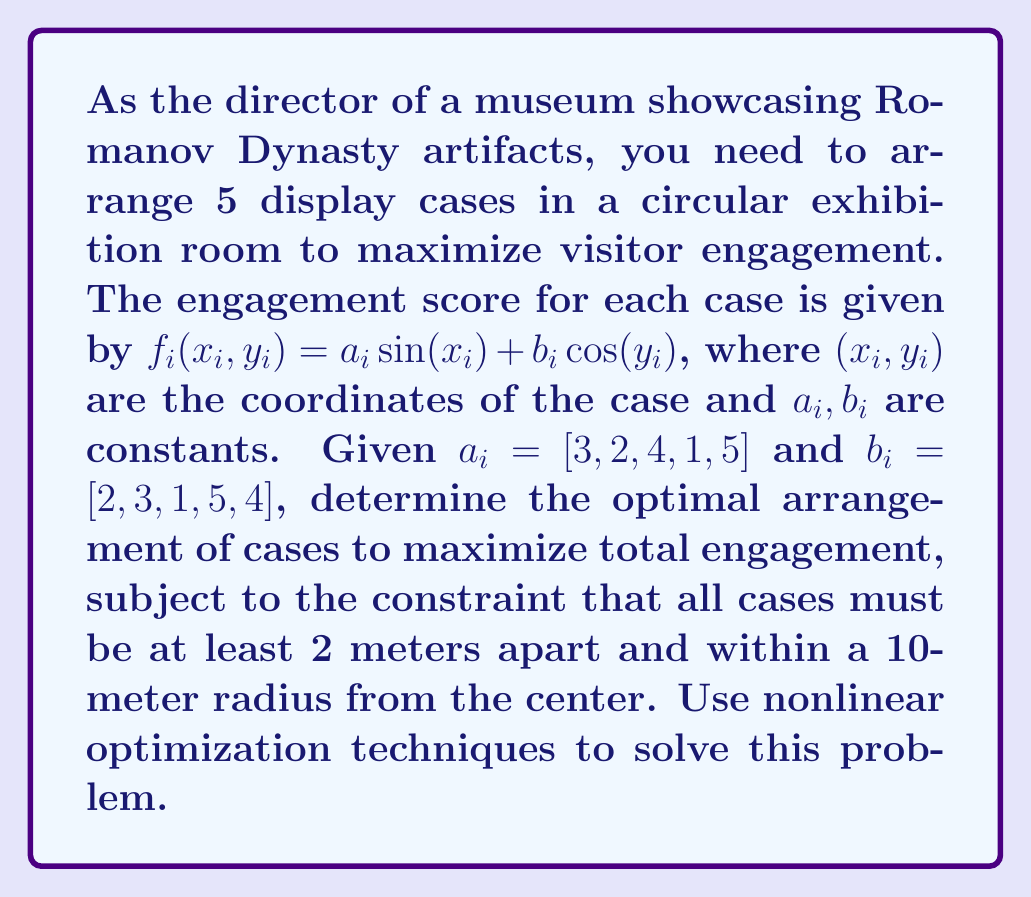Can you answer this question? To solve this nonlinear optimization problem, we'll follow these steps:

1) Define the objective function:
   $$f(x_1,y_1,x_2,y_2,x_3,y_3,x_4,y_4,x_5,y_5) = \sum_{i=1}^5 (a_i \sin(x_i) + b_i \cos(y_i))$$

2) Define the constraints:
   a) Distance between cases: For all $i \neq j$,
      $$\sqrt{(x_i-x_j)^2 + (y_i-y_j)^2} \geq 2$$
   b) Within 10-meter radius:
      $$x_i^2 + y_i^2 \leq 100$$ for all $i$

3) This is a nonlinear programming problem with nonlinear constraints. We can use sequential quadratic programming (SQP) or interior point methods to solve it.

4) Using a numerical optimization software (e.g., MATLAB's fmincon or Python's scipy.optimize.minimize), we can solve this problem. The exact implementation would depend on the software used.

5) The optimization algorithm would iteratively adjust the positions of the cases to maximize the objective function while satisfying the constraints.

6) The solution would provide the optimal $(x_i, y_i)$ coordinates for each case.

7) The maximum engagement score would be the sum of individual case scores at these optimal positions.

Note: Due to the complexity of this problem and the potential for multiple local optima, it's advisable to run the optimization multiple times with different initial conditions to increase the likelihood of finding the global optimum.
Answer: Optimal $(x_i, y_i)$ coordinates for each case, maximizing $\sum_{i=1}^5 (a_i \sin(x_i) + b_i \cos(y_i))$ subject to given constraints. 